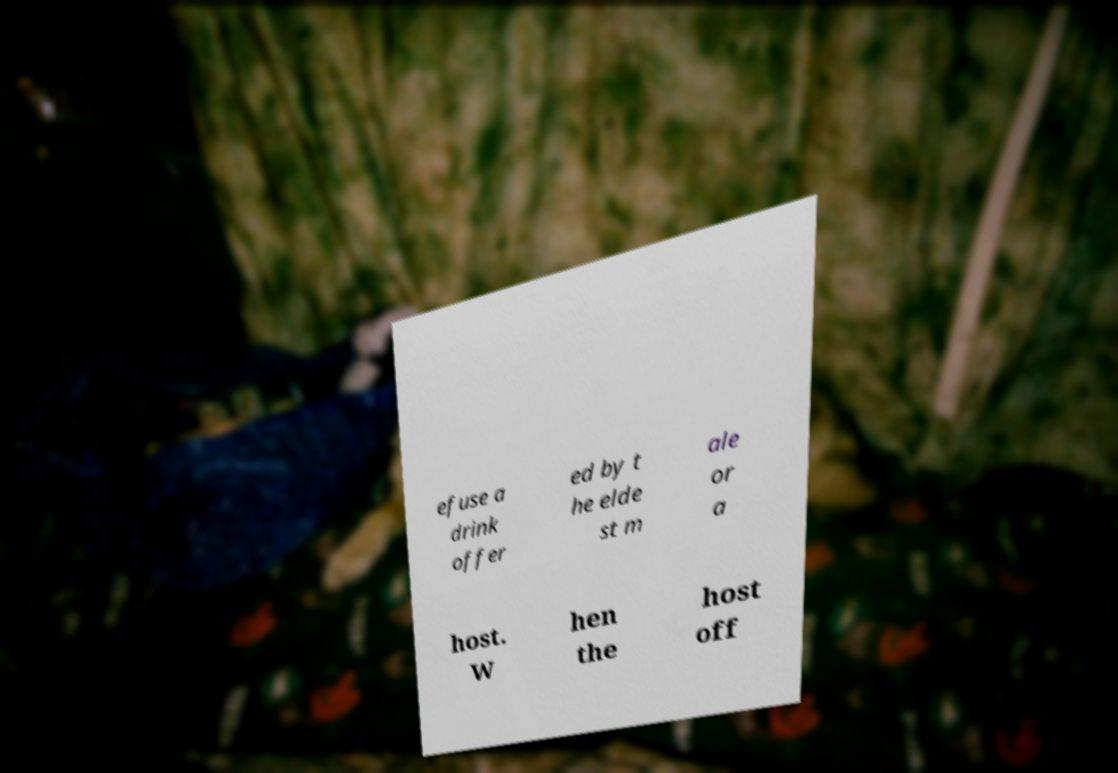I need the written content from this picture converted into text. Can you do that? efuse a drink offer ed by t he elde st m ale or a host. W hen the host off 